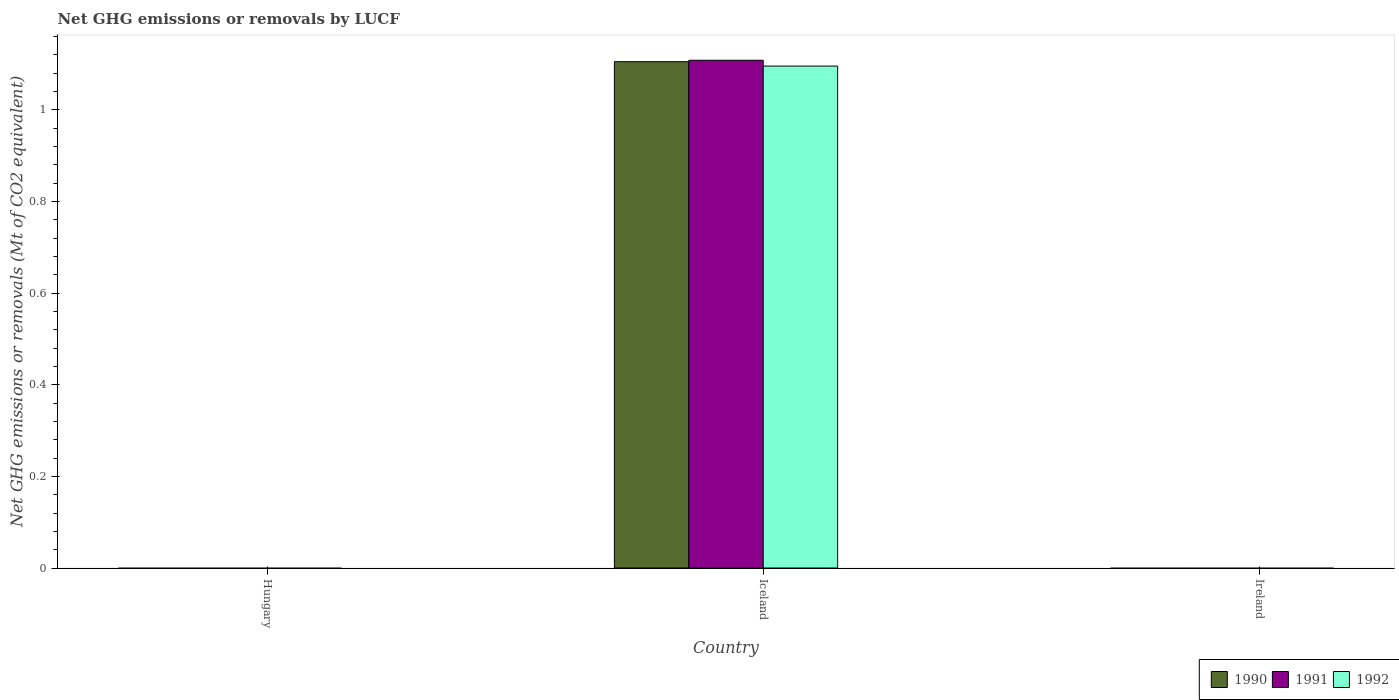How many different coloured bars are there?
Ensure brevity in your answer.  3. Are the number of bars per tick equal to the number of legend labels?
Keep it short and to the point. No. How many bars are there on the 1st tick from the left?
Offer a terse response. 0. How many bars are there on the 1st tick from the right?
Make the answer very short. 0. In how many cases, is the number of bars for a given country not equal to the number of legend labels?
Give a very brief answer. 2. What is the net GHG emissions or removals by LUCF in 1990 in Iceland?
Your answer should be very brief. 1.1. Across all countries, what is the maximum net GHG emissions or removals by LUCF in 1991?
Keep it short and to the point. 1.11. In which country was the net GHG emissions or removals by LUCF in 1992 maximum?
Keep it short and to the point. Iceland. What is the total net GHG emissions or removals by LUCF in 1990 in the graph?
Provide a succinct answer. 1.1. What is the difference between the net GHG emissions or removals by LUCF in 1992 in Iceland and the net GHG emissions or removals by LUCF in 1991 in Hungary?
Your answer should be compact. 1.1. What is the average net GHG emissions or removals by LUCF in 1991 per country?
Make the answer very short. 0.37. What is the difference between the net GHG emissions or removals by LUCF of/in 1992 and net GHG emissions or removals by LUCF of/in 1990 in Iceland?
Provide a short and direct response. -0.01. In how many countries, is the net GHG emissions or removals by LUCF in 1992 greater than 0.48000000000000004 Mt?
Keep it short and to the point. 1. What is the difference between the highest and the lowest net GHG emissions or removals by LUCF in 1992?
Offer a terse response. 1.1. How many bars are there?
Provide a short and direct response. 3. Are the values on the major ticks of Y-axis written in scientific E-notation?
Provide a succinct answer. No. Does the graph contain any zero values?
Ensure brevity in your answer.  Yes. Where does the legend appear in the graph?
Give a very brief answer. Bottom right. How are the legend labels stacked?
Offer a very short reply. Horizontal. What is the title of the graph?
Make the answer very short. Net GHG emissions or removals by LUCF. What is the label or title of the Y-axis?
Make the answer very short. Net GHG emissions or removals (Mt of CO2 equivalent). What is the Net GHG emissions or removals (Mt of CO2 equivalent) in 1990 in Hungary?
Offer a terse response. 0. What is the Net GHG emissions or removals (Mt of CO2 equivalent) in 1991 in Hungary?
Offer a terse response. 0. What is the Net GHG emissions or removals (Mt of CO2 equivalent) of 1992 in Hungary?
Your answer should be compact. 0. What is the Net GHG emissions or removals (Mt of CO2 equivalent) in 1990 in Iceland?
Offer a terse response. 1.1. What is the Net GHG emissions or removals (Mt of CO2 equivalent) of 1991 in Iceland?
Give a very brief answer. 1.11. What is the Net GHG emissions or removals (Mt of CO2 equivalent) in 1992 in Iceland?
Provide a succinct answer. 1.1. What is the Net GHG emissions or removals (Mt of CO2 equivalent) of 1990 in Ireland?
Provide a succinct answer. 0. What is the Net GHG emissions or removals (Mt of CO2 equivalent) of 1991 in Ireland?
Offer a very short reply. 0. Across all countries, what is the maximum Net GHG emissions or removals (Mt of CO2 equivalent) of 1990?
Your response must be concise. 1.1. Across all countries, what is the maximum Net GHG emissions or removals (Mt of CO2 equivalent) of 1991?
Provide a succinct answer. 1.11. Across all countries, what is the maximum Net GHG emissions or removals (Mt of CO2 equivalent) of 1992?
Offer a very short reply. 1.1. What is the total Net GHG emissions or removals (Mt of CO2 equivalent) in 1990 in the graph?
Ensure brevity in your answer.  1.1. What is the total Net GHG emissions or removals (Mt of CO2 equivalent) of 1991 in the graph?
Keep it short and to the point. 1.11. What is the total Net GHG emissions or removals (Mt of CO2 equivalent) of 1992 in the graph?
Offer a very short reply. 1.1. What is the average Net GHG emissions or removals (Mt of CO2 equivalent) of 1990 per country?
Keep it short and to the point. 0.37. What is the average Net GHG emissions or removals (Mt of CO2 equivalent) in 1991 per country?
Your response must be concise. 0.37. What is the average Net GHG emissions or removals (Mt of CO2 equivalent) in 1992 per country?
Offer a terse response. 0.36. What is the difference between the Net GHG emissions or removals (Mt of CO2 equivalent) in 1990 and Net GHG emissions or removals (Mt of CO2 equivalent) in 1991 in Iceland?
Your answer should be very brief. -0. What is the difference between the Net GHG emissions or removals (Mt of CO2 equivalent) of 1990 and Net GHG emissions or removals (Mt of CO2 equivalent) of 1992 in Iceland?
Provide a succinct answer. 0.01. What is the difference between the Net GHG emissions or removals (Mt of CO2 equivalent) in 1991 and Net GHG emissions or removals (Mt of CO2 equivalent) in 1992 in Iceland?
Keep it short and to the point. 0.01. What is the difference between the highest and the lowest Net GHG emissions or removals (Mt of CO2 equivalent) in 1990?
Offer a very short reply. 1.1. What is the difference between the highest and the lowest Net GHG emissions or removals (Mt of CO2 equivalent) of 1991?
Offer a very short reply. 1.11. What is the difference between the highest and the lowest Net GHG emissions or removals (Mt of CO2 equivalent) of 1992?
Offer a terse response. 1.1. 